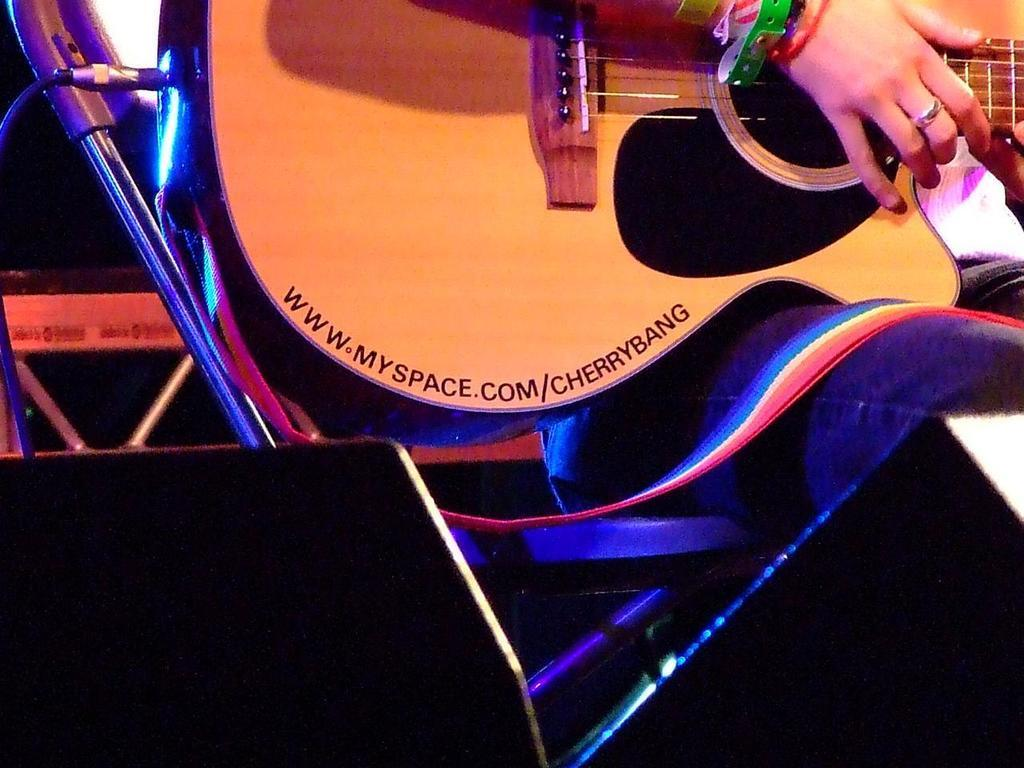What musical instrument is partially shown in the image? A half part of a guitar is displayed in the image. Is there any text on the guitar? Yes, the text "myspace.com/cherrybang" is written on the guitar. What is connected to the bottom of the guitar? There is a wire cord connected to the bottom of the guitar. How does the guitar cook a meal in the image? The guitar does not cook a meal in the image; it is a musical instrument with text and a wire cord connected to it. 